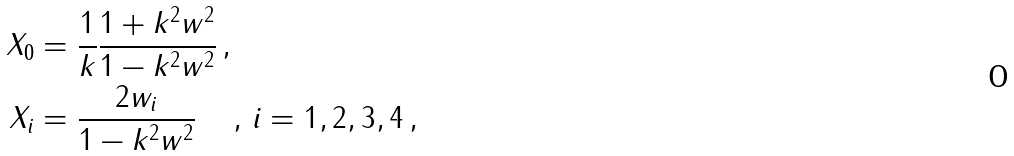<formula> <loc_0><loc_0><loc_500><loc_500>X _ { 0 } & = \frac { 1 } { k } \frac { 1 + k ^ { 2 } w ^ { 2 } } { 1 - k ^ { 2 } w ^ { 2 } } \, , \\ X _ { i } & = \frac { 2 w _ { i } } { 1 - k ^ { 2 } w ^ { 2 } } \, \quad , \, i = 1 , 2 , 3 , 4 \, ,</formula> 